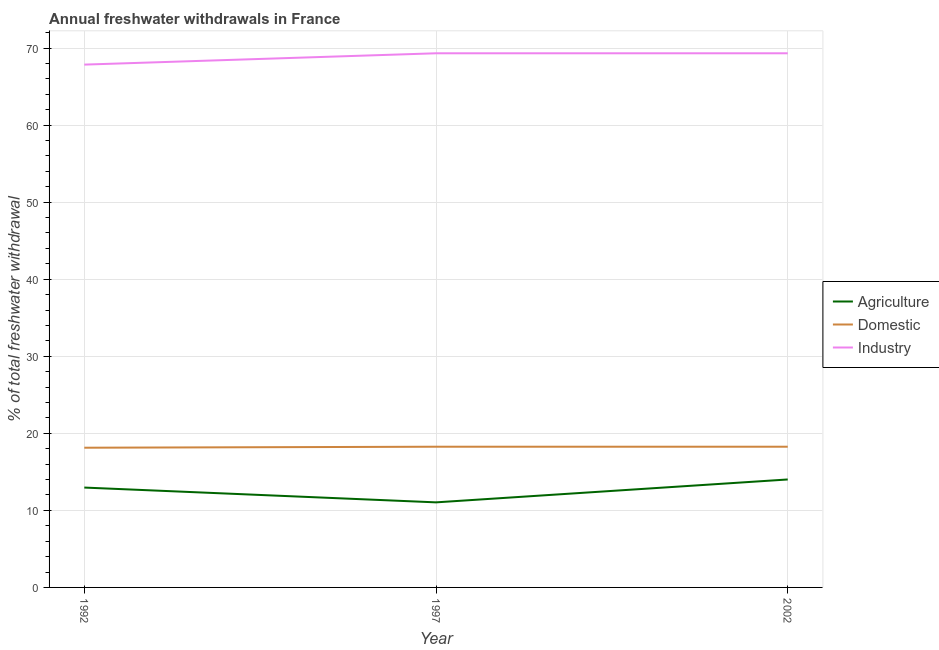Is the number of lines equal to the number of legend labels?
Your answer should be very brief. Yes. What is the percentage of freshwater withdrawal for domestic purposes in 1997?
Give a very brief answer. 18.26. Across all years, what is the maximum percentage of freshwater withdrawal for domestic purposes?
Provide a short and direct response. 18.26. Across all years, what is the minimum percentage of freshwater withdrawal for industry?
Your answer should be very brief. 67.85. In which year was the percentage of freshwater withdrawal for domestic purposes maximum?
Your response must be concise. 1997. What is the total percentage of freshwater withdrawal for industry in the graph?
Your response must be concise. 206.49. What is the difference between the percentage of freshwater withdrawal for agriculture in 1992 and that in 1997?
Your response must be concise. 1.92. What is the difference between the percentage of freshwater withdrawal for agriculture in 1992 and the percentage of freshwater withdrawal for industry in 2002?
Your answer should be very brief. -56.36. What is the average percentage of freshwater withdrawal for agriculture per year?
Ensure brevity in your answer.  12.67. In the year 2002, what is the difference between the percentage of freshwater withdrawal for domestic purposes and percentage of freshwater withdrawal for agriculture?
Give a very brief answer. 4.25. What is the ratio of the percentage of freshwater withdrawal for domestic purposes in 1992 to that in 2002?
Ensure brevity in your answer.  0.99. Is the difference between the percentage of freshwater withdrawal for domestic purposes in 1992 and 1997 greater than the difference between the percentage of freshwater withdrawal for industry in 1992 and 1997?
Make the answer very short. Yes. What is the difference between the highest and the second highest percentage of freshwater withdrawal for domestic purposes?
Offer a terse response. 0. What is the difference between the highest and the lowest percentage of freshwater withdrawal for industry?
Keep it short and to the point. 1.47. Is the sum of the percentage of freshwater withdrawal for domestic purposes in 1992 and 2002 greater than the maximum percentage of freshwater withdrawal for industry across all years?
Give a very brief answer. No. Does the percentage of freshwater withdrawal for industry monotonically increase over the years?
Your answer should be very brief. No. Is the percentage of freshwater withdrawal for industry strictly greater than the percentage of freshwater withdrawal for agriculture over the years?
Your answer should be very brief. Yes. Is the percentage of freshwater withdrawal for domestic purposes strictly less than the percentage of freshwater withdrawal for industry over the years?
Provide a succinct answer. Yes. What is the difference between two consecutive major ticks on the Y-axis?
Give a very brief answer. 10. Are the values on the major ticks of Y-axis written in scientific E-notation?
Offer a very short reply. No. Where does the legend appear in the graph?
Ensure brevity in your answer.  Center right. How are the legend labels stacked?
Your response must be concise. Vertical. What is the title of the graph?
Your response must be concise. Annual freshwater withdrawals in France. What is the label or title of the X-axis?
Offer a terse response. Year. What is the label or title of the Y-axis?
Your answer should be compact. % of total freshwater withdrawal. What is the % of total freshwater withdrawal of Agriculture in 1992?
Offer a terse response. 12.96. What is the % of total freshwater withdrawal in Domestic in 1992?
Provide a succinct answer. 18.13. What is the % of total freshwater withdrawal in Industry in 1992?
Offer a terse response. 67.85. What is the % of total freshwater withdrawal of Agriculture in 1997?
Provide a succinct answer. 11.04. What is the % of total freshwater withdrawal in Domestic in 1997?
Your response must be concise. 18.26. What is the % of total freshwater withdrawal of Industry in 1997?
Provide a succinct answer. 69.32. What is the % of total freshwater withdrawal of Agriculture in 2002?
Offer a very short reply. 14.01. What is the % of total freshwater withdrawal in Domestic in 2002?
Your response must be concise. 18.26. What is the % of total freshwater withdrawal of Industry in 2002?
Make the answer very short. 69.32. Across all years, what is the maximum % of total freshwater withdrawal of Agriculture?
Provide a short and direct response. 14.01. Across all years, what is the maximum % of total freshwater withdrawal of Domestic?
Ensure brevity in your answer.  18.26. Across all years, what is the maximum % of total freshwater withdrawal in Industry?
Offer a very short reply. 69.32. Across all years, what is the minimum % of total freshwater withdrawal in Agriculture?
Offer a very short reply. 11.04. Across all years, what is the minimum % of total freshwater withdrawal in Domestic?
Keep it short and to the point. 18.13. Across all years, what is the minimum % of total freshwater withdrawal of Industry?
Offer a very short reply. 67.85. What is the total % of total freshwater withdrawal in Agriculture in the graph?
Give a very brief answer. 38.01. What is the total % of total freshwater withdrawal in Domestic in the graph?
Your answer should be compact. 54.65. What is the total % of total freshwater withdrawal in Industry in the graph?
Ensure brevity in your answer.  206.49. What is the difference between the % of total freshwater withdrawal in Agriculture in 1992 and that in 1997?
Provide a succinct answer. 1.92. What is the difference between the % of total freshwater withdrawal in Domestic in 1992 and that in 1997?
Your answer should be very brief. -0.13. What is the difference between the % of total freshwater withdrawal of Industry in 1992 and that in 1997?
Provide a succinct answer. -1.47. What is the difference between the % of total freshwater withdrawal of Agriculture in 1992 and that in 2002?
Your answer should be very brief. -1.05. What is the difference between the % of total freshwater withdrawal in Domestic in 1992 and that in 2002?
Provide a short and direct response. -0.13. What is the difference between the % of total freshwater withdrawal of Industry in 1992 and that in 2002?
Your response must be concise. -1.47. What is the difference between the % of total freshwater withdrawal of Agriculture in 1997 and that in 2002?
Your answer should be compact. -2.97. What is the difference between the % of total freshwater withdrawal in Agriculture in 1992 and the % of total freshwater withdrawal in Industry in 1997?
Make the answer very short. -56.36. What is the difference between the % of total freshwater withdrawal in Domestic in 1992 and the % of total freshwater withdrawal in Industry in 1997?
Your answer should be compact. -51.19. What is the difference between the % of total freshwater withdrawal in Agriculture in 1992 and the % of total freshwater withdrawal in Domestic in 2002?
Offer a very short reply. -5.3. What is the difference between the % of total freshwater withdrawal of Agriculture in 1992 and the % of total freshwater withdrawal of Industry in 2002?
Give a very brief answer. -56.36. What is the difference between the % of total freshwater withdrawal in Domestic in 1992 and the % of total freshwater withdrawal in Industry in 2002?
Offer a terse response. -51.19. What is the difference between the % of total freshwater withdrawal of Agriculture in 1997 and the % of total freshwater withdrawal of Domestic in 2002?
Provide a short and direct response. -7.22. What is the difference between the % of total freshwater withdrawal of Agriculture in 1997 and the % of total freshwater withdrawal of Industry in 2002?
Your answer should be very brief. -58.28. What is the difference between the % of total freshwater withdrawal in Domestic in 1997 and the % of total freshwater withdrawal in Industry in 2002?
Give a very brief answer. -51.06. What is the average % of total freshwater withdrawal in Agriculture per year?
Keep it short and to the point. 12.67. What is the average % of total freshwater withdrawal of Domestic per year?
Ensure brevity in your answer.  18.22. What is the average % of total freshwater withdrawal of Industry per year?
Give a very brief answer. 68.83. In the year 1992, what is the difference between the % of total freshwater withdrawal in Agriculture and % of total freshwater withdrawal in Domestic?
Provide a succinct answer. -5.17. In the year 1992, what is the difference between the % of total freshwater withdrawal of Agriculture and % of total freshwater withdrawal of Industry?
Ensure brevity in your answer.  -54.89. In the year 1992, what is the difference between the % of total freshwater withdrawal of Domestic and % of total freshwater withdrawal of Industry?
Ensure brevity in your answer.  -49.72. In the year 1997, what is the difference between the % of total freshwater withdrawal of Agriculture and % of total freshwater withdrawal of Domestic?
Ensure brevity in your answer.  -7.22. In the year 1997, what is the difference between the % of total freshwater withdrawal in Agriculture and % of total freshwater withdrawal in Industry?
Provide a succinct answer. -58.28. In the year 1997, what is the difference between the % of total freshwater withdrawal in Domestic and % of total freshwater withdrawal in Industry?
Your answer should be compact. -51.06. In the year 2002, what is the difference between the % of total freshwater withdrawal in Agriculture and % of total freshwater withdrawal in Domestic?
Your answer should be very brief. -4.25. In the year 2002, what is the difference between the % of total freshwater withdrawal in Agriculture and % of total freshwater withdrawal in Industry?
Your answer should be very brief. -55.31. In the year 2002, what is the difference between the % of total freshwater withdrawal of Domestic and % of total freshwater withdrawal of Industry?
Provide a short and direct response. -51.06. What is the ratio of the % of total freshwater withdrawal in Agriculture in 1992 to that in 1997?
Offer a very short reply. 1.17. What is the ratio of the % of total freshwater withdrawal of Industry in 1992 to that in 1997?
Offer a terse response. 0.98. What is the ratio of the % of total freshwater withdrawal in Agriculture in 1992 to that in 2002?
Your answer should be compact. 0.93. What is the ratio of the % of total freshwater withdrawal of Industry in 1992 to that in 2002?
Provide a short and direct response. 0.98. What is the ratio of the % of total freshwater withdrawal of Agriculture in 1997 to that in 2002?
Provide a short and direct response. 0.79. What is the difference between the highest and the second highest % of total freshwater withdrawal of Domestic?
Give a very brief answer. 0. What is the difference between the highest and the lowest % of total freshwater withdrawal in Agriculture?
Your response must be concise. 2.97. What is the difference between the highest and the lowest % of total freshwater withdrawal of Domestic?
Offer a terse response. 0.13. What is the difference between the highest and the lowest % of total freshwater withdrawal of Industry?
Your answer should be very brief. 1.47. 